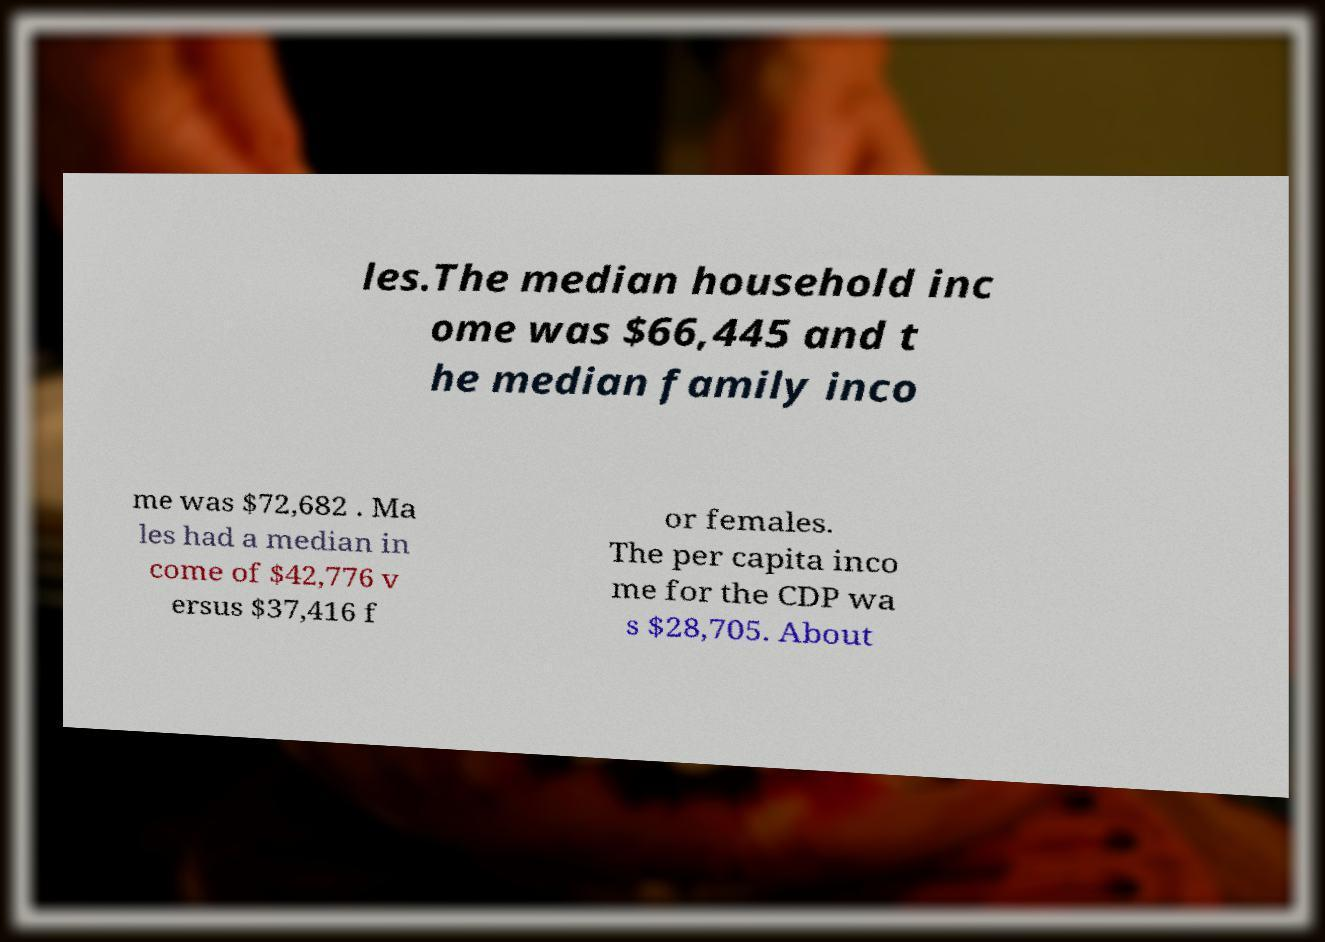Please identify and transcribe the text found in this image. les.The median household inc ome was $66,445 and t he median family inco me was $72,682 . Ma les had a median in come of $42,776 v ersus $37,416 f or females. The per capita inco me for the CDP wa s $28,705. About 